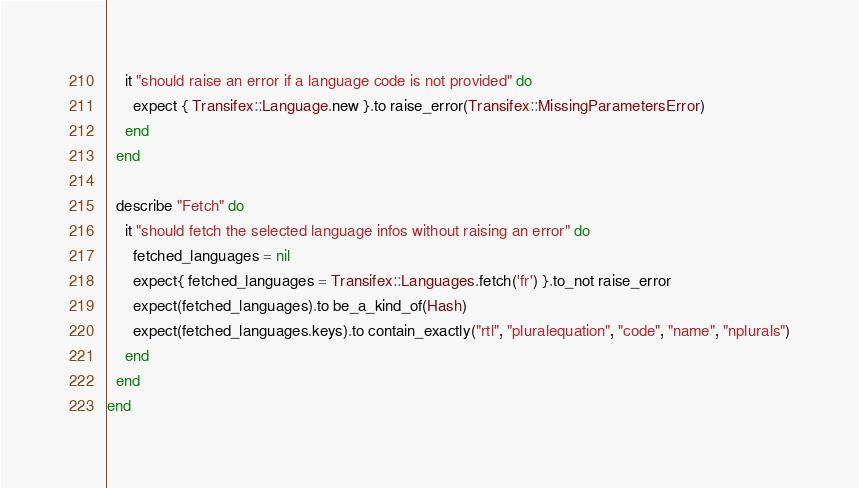<code> <loc_0><loc_0><loc_500><loc_500><_Ruby_>    it "should raise an error if a language code is not provided" do
      expect { Transifex::Language.new }.to raise_error(Transifex::MissingParametersError)
    end
  end 

  describe "Fetch" do
    it "should fetch the selected language infos without raising an error" do
      fetched_languages = nil
      expect{ fetched_languages = Transifex::Languages.fetch('fr') }.to_not raise_error
      expect(fetched_languages).to be_a_kind_of(Hash)
      expect(fetched_languages.keys).to contain_exactly("rtl", "pluralequation", "code", "name", "nplurals")
    end
  end
end</code> 